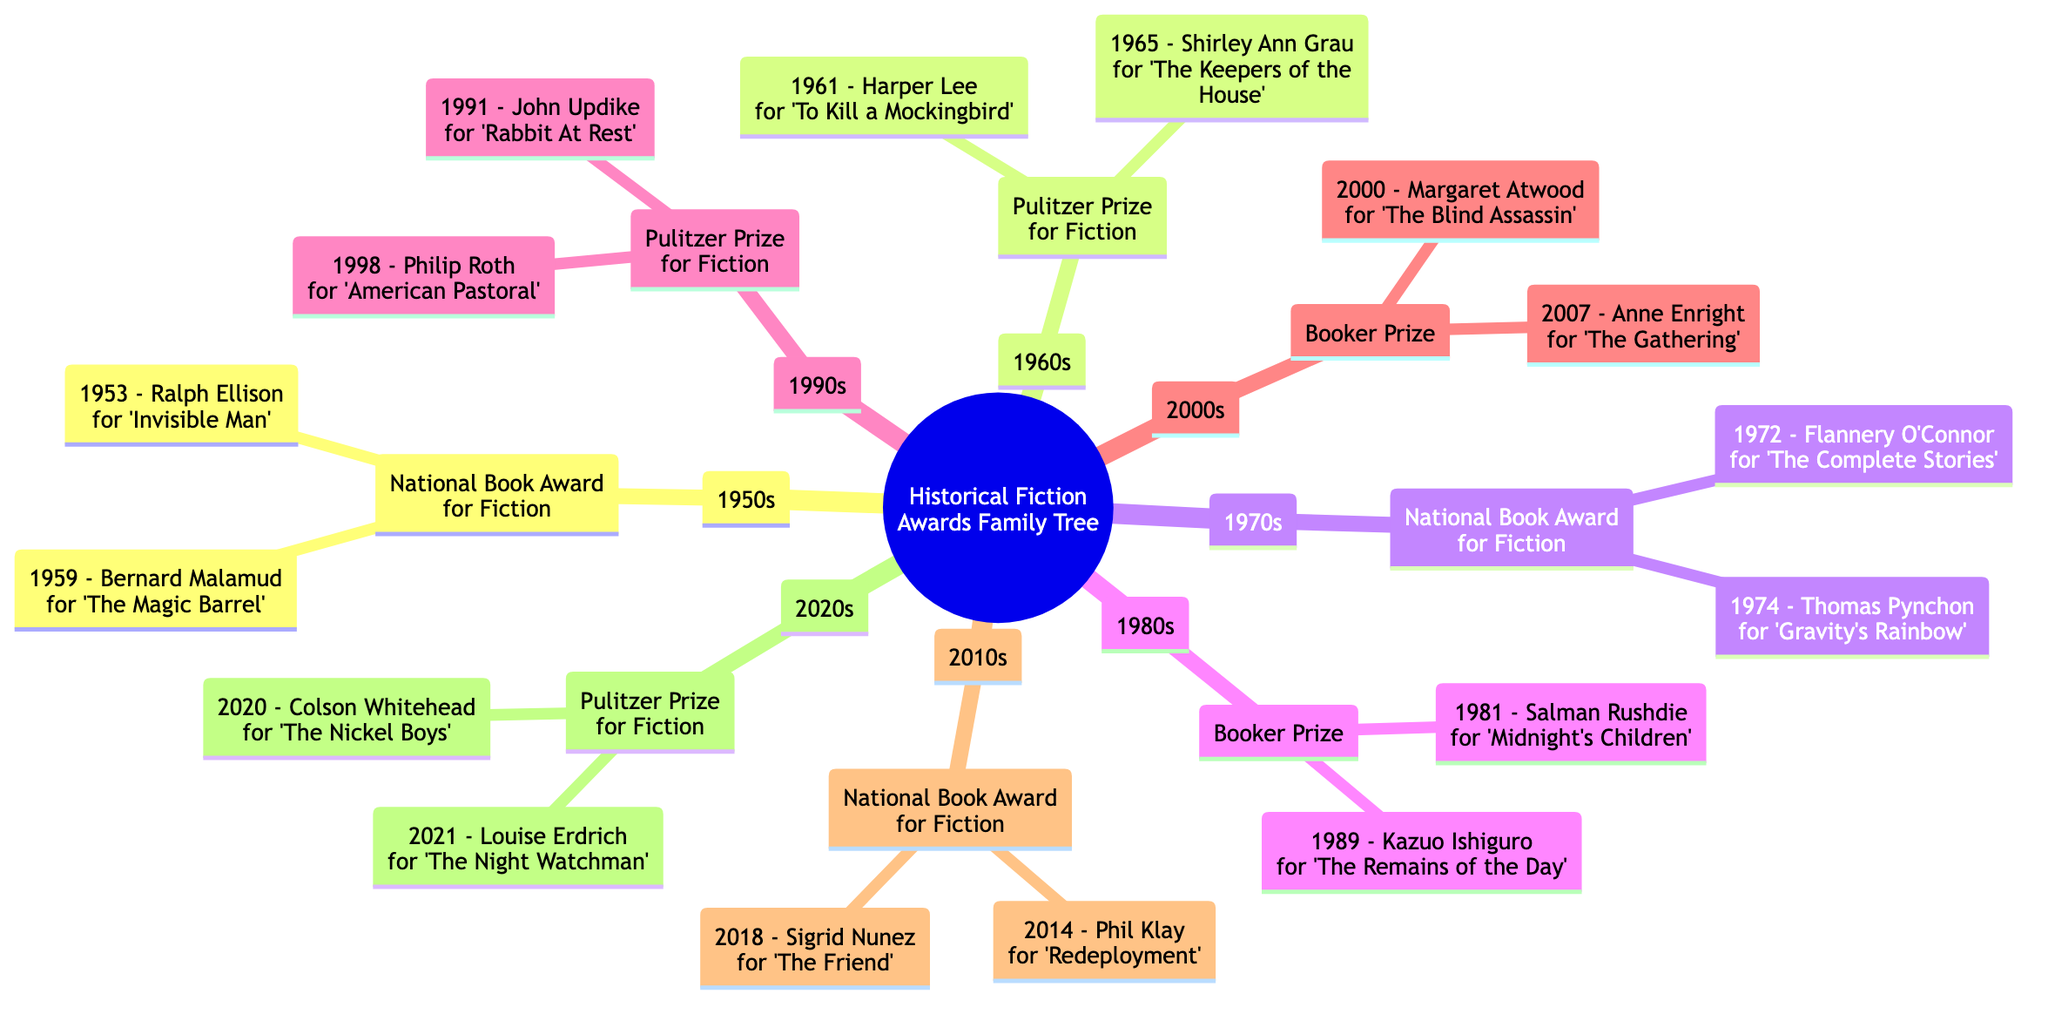What major award was given in the 1970s? The diagram indicates that the major award given in the 1970s was the National Book Award for Fiction, which is directly labeled in that section.
Answer: National Book Award for Fiction Who won the National Book Award in 2018? To find the recipient for the National Book Award in 2018, I look under the 2010s section, which has a child node labeled National Book Award for Fiction with the recipient named Sigrid Nunez for 'The Friend' listed under it.
Answer: Sigrid Nunez Which author won the Booker Prize in 1981? The Booker Prize node under the 1980s section shows two recipients. By identifying the node for 1981, I see that Salman Rushdie is listed as the recipient for that year.
Answer: Salman Rushdie How many Pulitzer Prize winners are shown in the 2000s? By examining the 2000s section of the diagram, I find that it includes only one award, the Booker Prize. It doesn't include any Pulitzer Prize winners, meaning there are zero under that category for the decade.
Answer: 0 In which decade did Colson Whitehead win the Pulitzer Prize for Fiction? Looking at the 2020s section of the diagram, I find the Pulitzer Prize for Fiction is listed, and under it, Colson Whitehead is named as the winner for the year 2020. Thus, his win falls within the 2020s decade.
Answer: 2020s Which author received a Pulitzer Prize in 1998? The diagram identifies the Pulitzer Prize for Fiction in the 1990s, where it lists Philip Roth as the recipient for the year 1998.
Answer: Philip Roth What is the total number of awards listed in the diagram? By counting all distinct award categories listed in the diagram across the decades, I see that there are a total of 7 award categories mentioned, considering all decades from the 1950s to the 2020s.
Answer: 7 What notable trend can be observed about the awards over time? Analyzing the diagram's structure, it's evident that the Pulitzer Prize for Fiction and the National Book Award for Fiction occur multiple times over the decades, suggesting these awards have a consistent presence in historical fiction recognition.
Answer: Consistent presence of Pulitzer Prize and National Book Award 